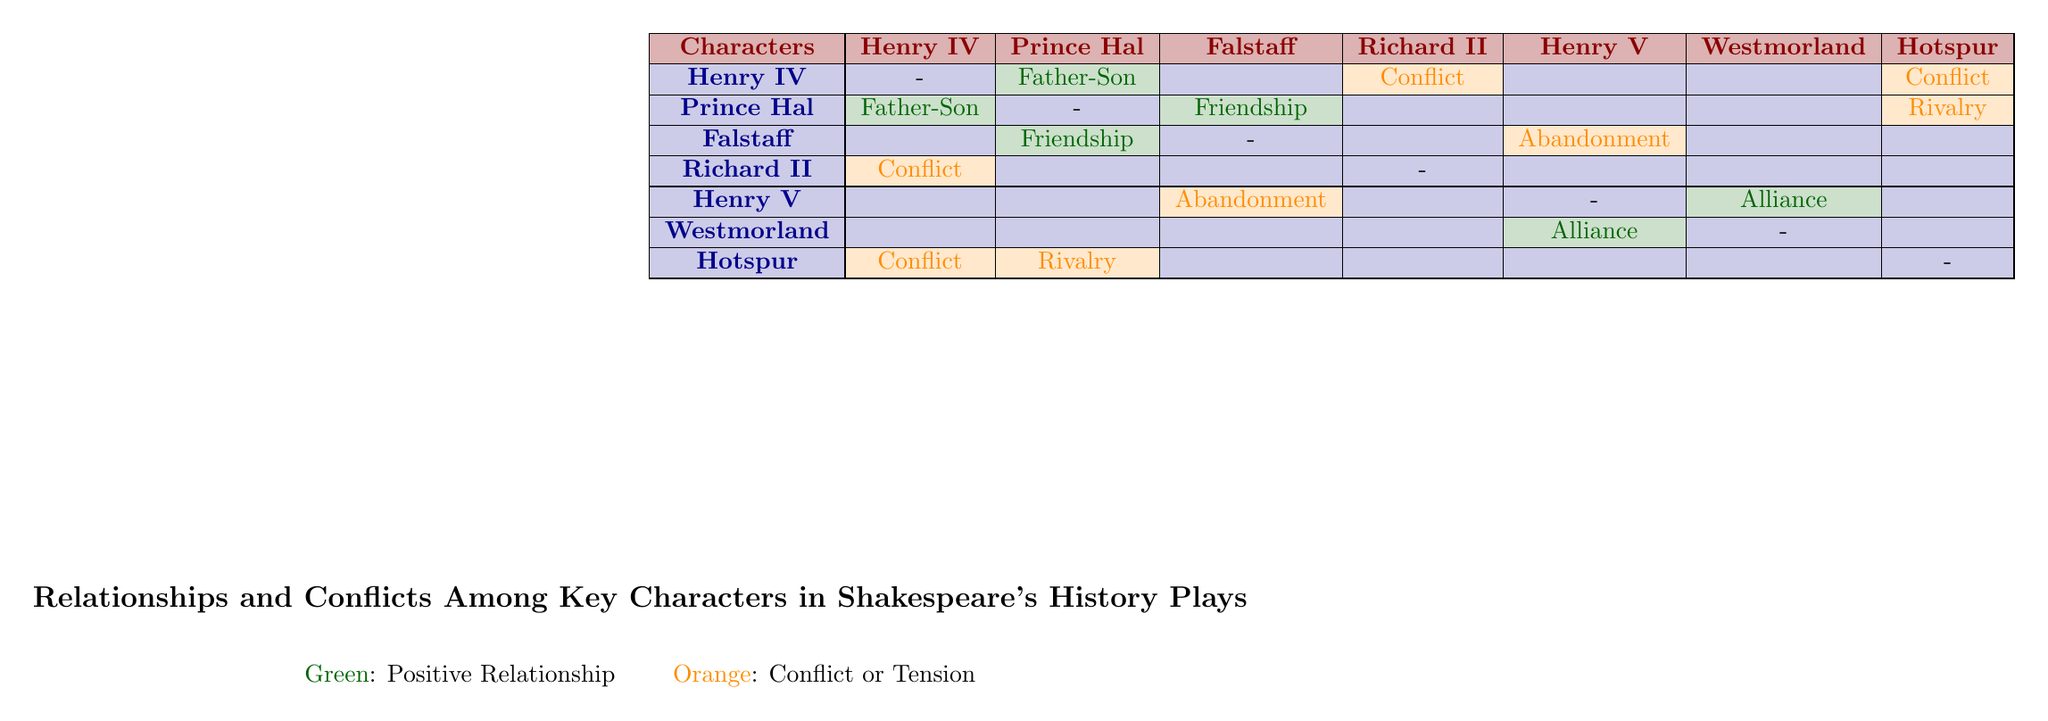What type of relationship exists between Henry IV and Prince Hal? The table indicates a "Father-Son" relationship between Henry IV and Prince Hal, which is marked in green.
Answer: Father-Son Is there a rivalry involving Prince Hal? The table shows that Prince Hal has a rivalry with Hotspur, highlighted in orange, indicating conflict.
Answer: Yes How many conflicts involve Henry IV? Looking at the interactions involving Henry IV, he is in conflict with Hotspur and Richard II, making it a total of two conflicts.
Answer: 2 What is the nature of the relationship between Henry V and Westmorland? The table describes their relationship as an "Alliance," marked in green, signifying a positive connection based on military support.
Answer: Alliance Which character does Falstaff have a friendship with? Falstaff's relationship with Prince Hal is labeled as "Friendship," denoted in green in the table.
Answer: Prince Hal Is Henry II involved in any conflicts with other characters? The table shows that Henry II is not listed as a character, so the answer is no, as there is no information about conflicts related to him.
Answer: No What type of relationship does Henry V have with Falstaff? The table indicates that Henry V's relationship with Falstaff is characterized by "Abandonment," shown in orange.
Answer: Abandonment Which character has the most types of relationships (including conflicts) listed in the table? By examining the relationships, Prince Hal has three types: Father-Son with Henry IV, Friendship with Falstaff, and Rivalry with Hotspur, making him the character with the most diverse relationships.
Answer: Prince Hal In total, how many relationships of any kind does Henry IV have? Henry IV has three relationships: one with Prince Hal (Father-Son), one with Hotspur (Conflict), and one with Richard II (Conflict), totaling three relationships.
Answer: 3 